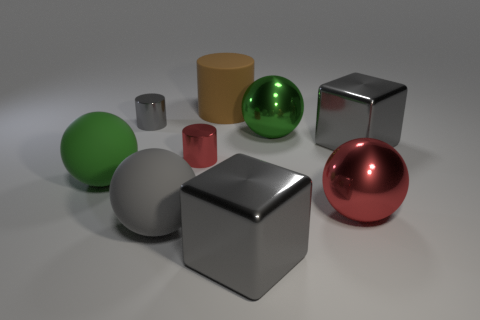How many green spheres must be subtracted to get 1 green spheres? 1 Subtract all shiny cylinders. How many cylinders are left? 1 Subtract all red balls. How many balls are left? 3 Subtract all large red metal cylinders. Subtract all red metallic cylinders. How many objects are left? 8 Add 4 big matte cylinders. How many big matte cylinders are left? 5 Add 5 gray objects. How many gray objects exist? 9 Add 1 small blue rubber blocks. How many objects exist? 10 Subtract 0 purple spheres. How many objects are left? 9 Subtract all blocks. How many objects are left? 7 Subtract 2 spheres. How many spheres are left? 2 